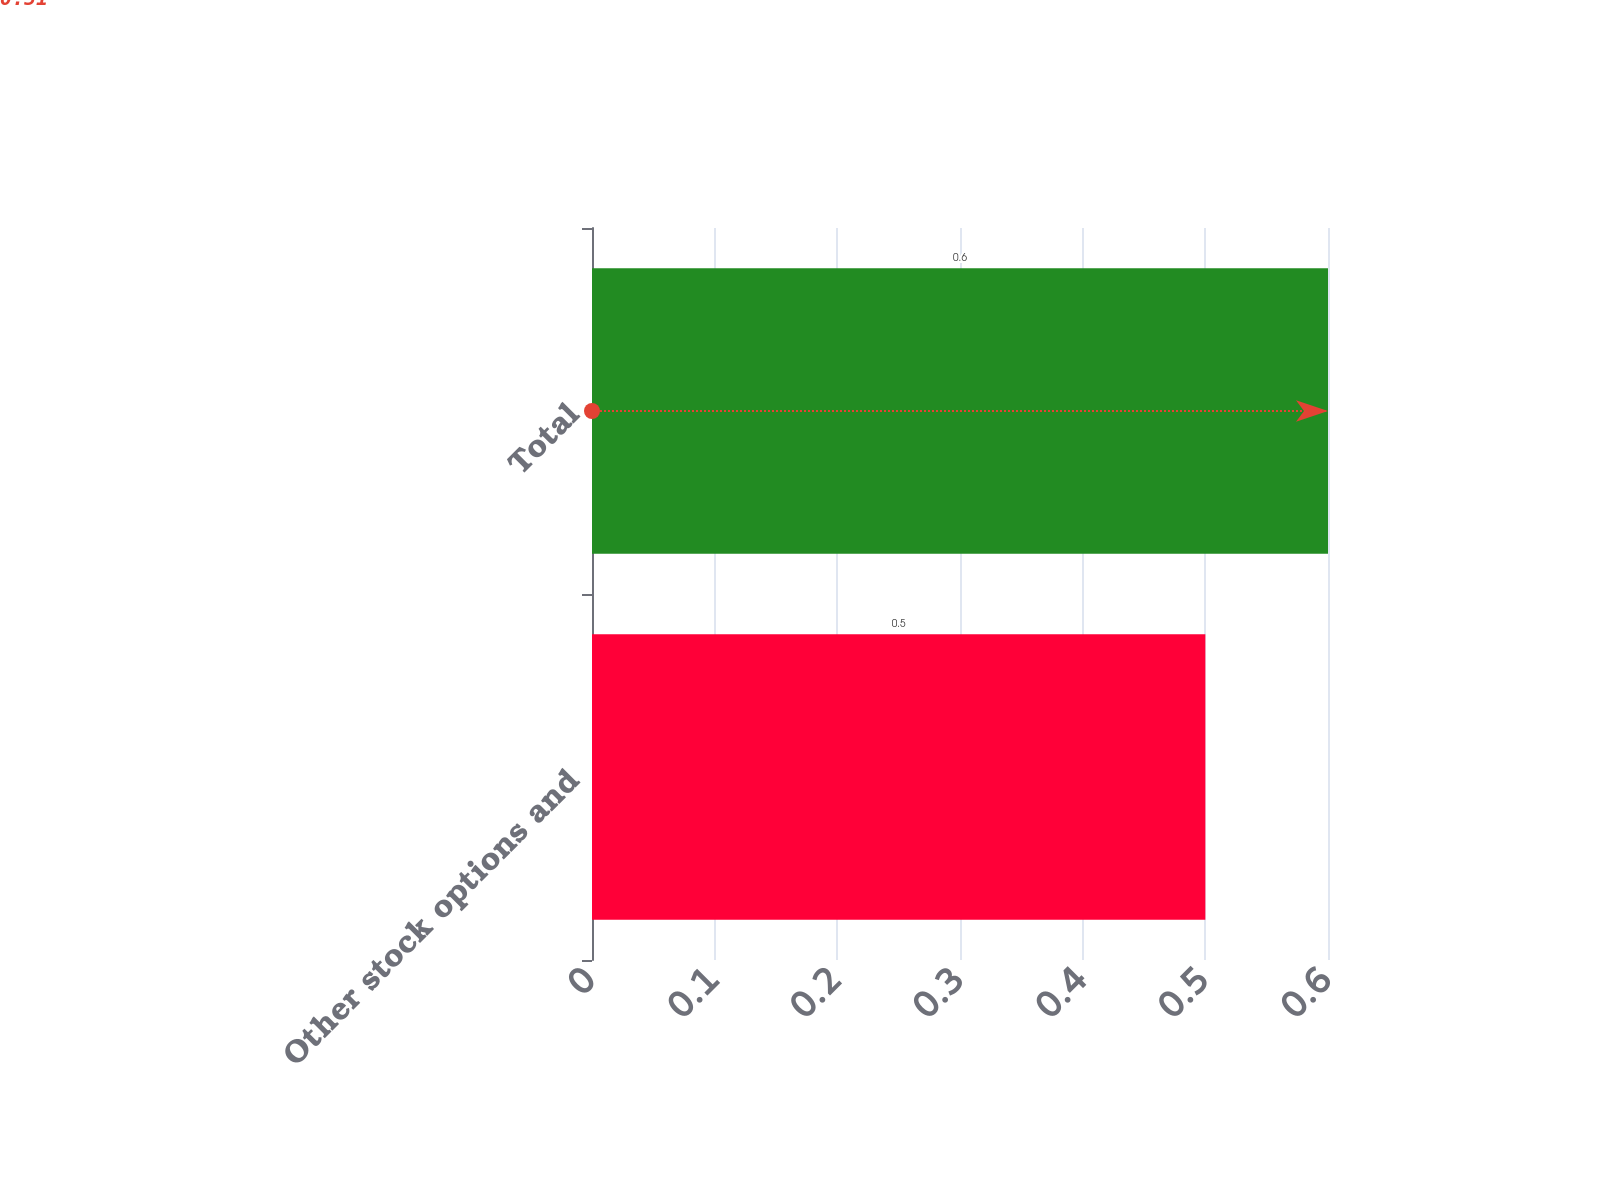Convert chart to OTSL. <chart><loc_0><loc_0><loc_500><loc_500><bar_chart><fcel>Other stock options and<fcel>Total<nl><fcel>0.5<fcel>0.6<nl></chart> 